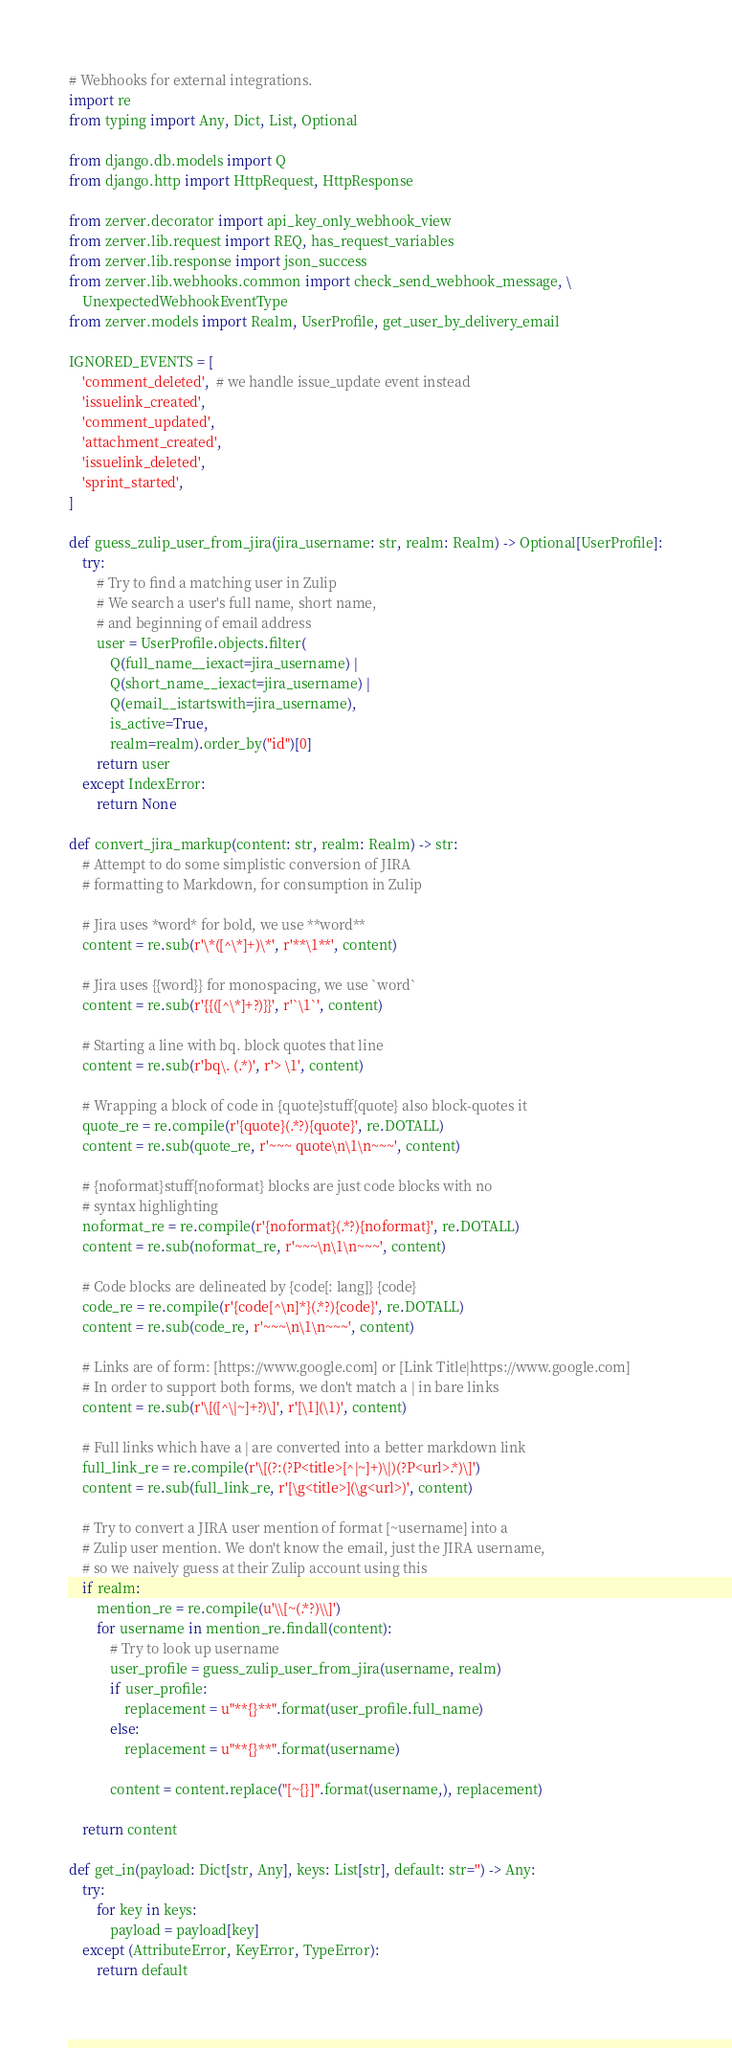Convert code to text. <code><loc_0><loc_0><loc_500><loc_500><_Python_># Webhooks for external integrations.
import re
from typing import Any, Dict, List, Optional

from django.db.models import Q
from django.http import HttpRequest, HttpResponse

from zerver.decorator import api_key_only_webhook_view
from zerver.lib.request import REQ, has_request_variables
from zerver.lib.response import json_success
from zerver.lib.webhooks.common import check_send_webhook_message, \
    UnexpectedWebhookEventType
from zerver.models import Realm, UserProfile, get_user_by_delivery_email

IGNORED_EVENTS = [
    'comment_deleted',  # we handle issue_update event instead
    'issuelink_created',
    'comment_updated',
    'attachment_created',
    'issuelink_deleted',
    'sprint_started',
]

def guess_zulip_user_from_jira(jira_username: str, realm: Realm) -> Optional[UserProfile]:
    try:
        # Try to find a matching user in Zulip
        # We search a user's full name, short name,
        # and beginning of email address
        user = UserProfile.objects.filter(
            Q(full_name__iexact=jira_username) |
            Q(short_name__iexact=jira_username) |
            Q(email__istartswith=jira_username),
            is_active=True,
            realm=realm).order_by("id")[0]
        return user
    except IndexError:
        return None

def convert_jira_markup(content: str, realm: Realm) -> str:
    # Attempt to do some simplistic conversion of JIRA
    # formatting to Markdown, for consumption in Zulip

    # Jira uses *word* for bold, we use **word**
    content = re.sub(r'\*([^\*]+)\*', r'**\1**', content)

    # Jira uses {{word}} for monospacing, we use `word`
    content = re.sub(r'{{([^\*]+?)}}', r'`\1`', content)

    # Starting a line with bq. block quotes that line
    content = re.sub(r'bq\. (.*)', r'> \1', content)

    # Wrapping a block of code in {quote}stuff{quote} also block-quotes it
    quote_re = re.compile(r'{quote}(.*?){quote}', re.DOTALL)
    content = re.sub(quote_re, r'~~~ quote\n\1\n~~~', content)

    # {noformat}stuff{noformat} blocks are just code blocks with no
    # syntax highlighting
    noformat_re = re.compile(r'{noformat}(.*?){noformat}', re.DOTALL)
    content = re.sub(noformat_re, r'~~~\n\1\n~~~', content)

    # Code blocks are delineated by {code[: lang]} {code}
    code_re = re.compile(r'{code[^\n]*}(.*?){code}', re.DOTALL)
    content = re.sub(code_re, r'~~~\n\1\n~~~', content)

    # Links are of form: [https://www.google.com] or [Link Title|https://www.google.com]
    # In order to support both forms, we don't match a | in bare links
    content = re.sub(r'\[([^\|~]+?)\]', r'[\1](\1)', content)

    # Full links which have a | are converted into a better markdown link
    full_link_re = re.compile(r'\[(?:(?P<title>[^|~]+)\|)(?P<url>.*)\]')
    content = re.sub(full_link_re, r'[\g<title>](\g<url>)', content)

    # Try to convert a JIRA user mention of format [~username] into a
    # Zulip user mention. We don't know the email, just the JIRA username,
    # so we naively guess at their Zulip account using this
    if realm:
        mention_re = re.compile(u'\\[~(.*?)\\]')
        for username in mention_re.findall(content):
            # Try to look up username
            user_profile = guess_zulip_user_from_jira(username, realm)
            if user_profile:
                replacement = u"**{}**".format(user_profile.full_name)
            else:
                replacement = u"**{}**".format(username)

            content = content.replace("[~{}]".format(username,), replacement)

    return content

def get_in(payload: Dict[str, Any], keys: List[str], default: str='') -> Any:
    try:
        for key in keys:
            payload = payload[key]
    except (AttributeError, KeyError, TypeError):
        return default</code> 